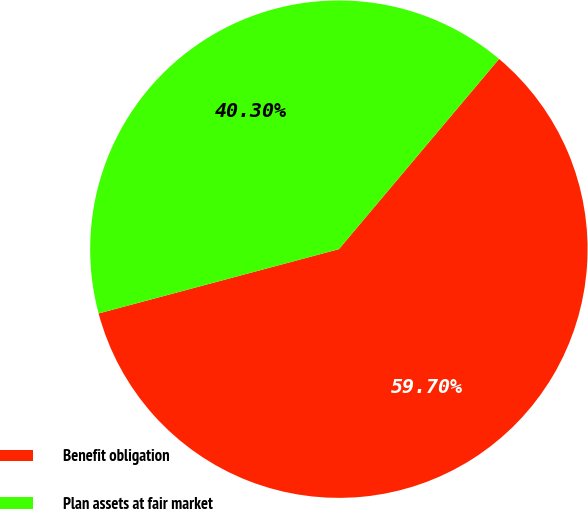Convert chart. <chart><loc_0><loc_0><loc_500><loc_500><pie_chart><fcel>Benefit obligation<fcel>Plan assets at fair market<nl><fcel>59.7%<fcel>40.3%<nl></chart> 